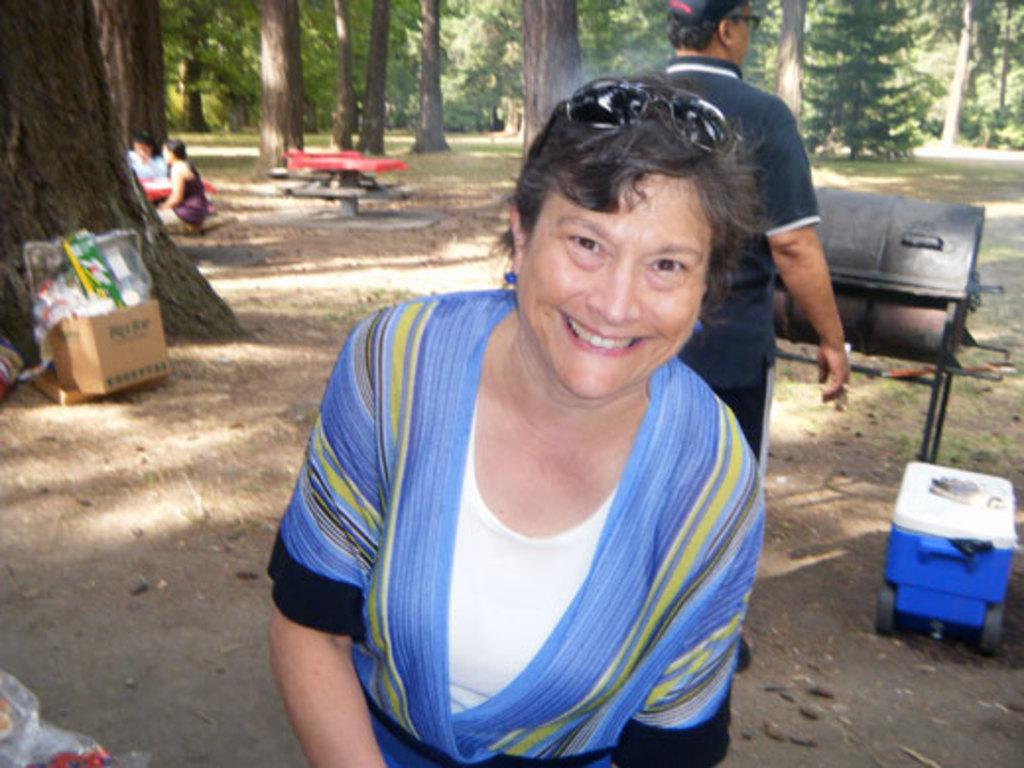What is the primary subject of the image? There is a woman in the image. What is the woman doing in the image? The woman is standing and smiling. What can be seen in the background of the image? There are people, boxes, plastic covers, and trees in the background of the image. What type of skin condition can be seen on the woman's face in the image? There is no indication of any skin condition on the woman's face in the image. What color is the woman's underwear in the image? The image does not show the woman's underwear, so it cannot be determined from the image. 